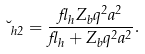<formula> <loc_0><loc_0><loc_500><loc_500>\lambda _ { h 2 } = \frac { \gamma _ { h } Z _ { b } q ^ { 2 } a ^ { 2 } } { \gamma _ { h } + Z _ { b } q ^ { 2 } a ^ { 2 } } .</formula> 